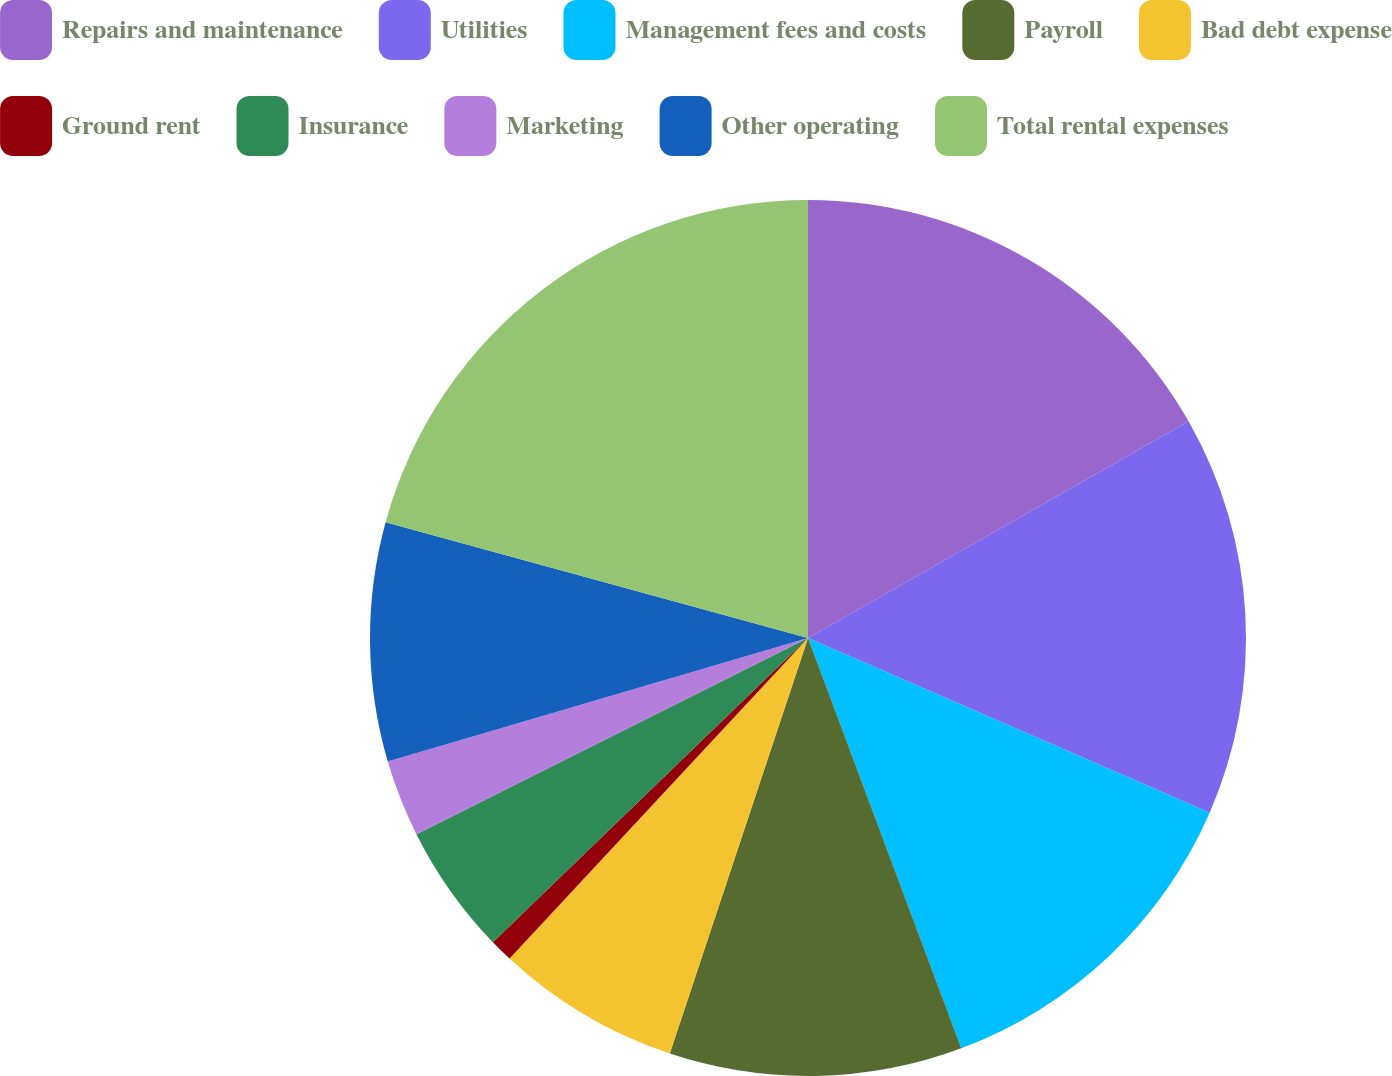<chart> <loc_0><loc_0><loc_500><loc_500><pie_chart><fcel>Repairs and maintenance<fcel>Utilities<fcel>Management fees and costs<fcel>Payroll<fcel>Bad debt expense<fcel>Ground rent<fcel>Insurance<fcel>Marketing<fcel>Other operating<fcel>Total rental expenses<nl><fcel>16.76%<fcel>14.77%<fcel>12.78%<fcel>10.8%<fcel>6.82%<fcel>0.85%<fcel>4.83%<fcel>2.84%<fcel>8.81%<fcel>20.74%<nl></chart> 